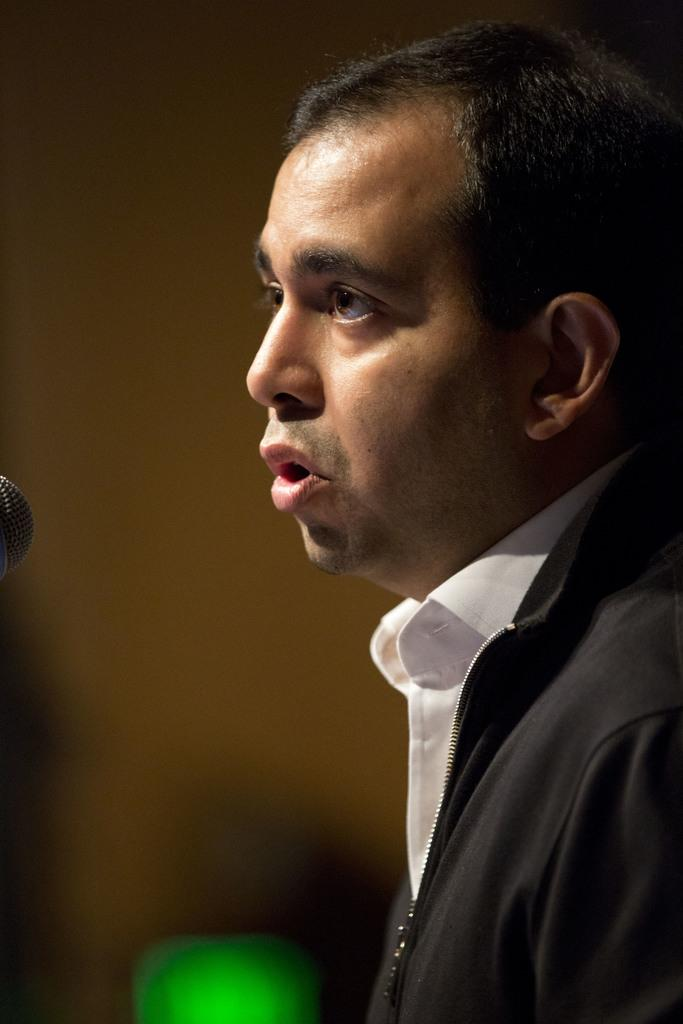Who is present in the image? There is a man in the image. What is the man wearing on his upper body? The man is wearing a black jacket and a white shirt. What type of store is the man managing in the image? There is no store present in the image, and the man's occupation is not mentioned. 